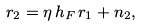<formula> <loc_0><loc_0><loc_500><loc_500>r _ { 2 } = \eta \, h _ { F } \, r _ { 1 } + n _ { 2 } ,</formula> 